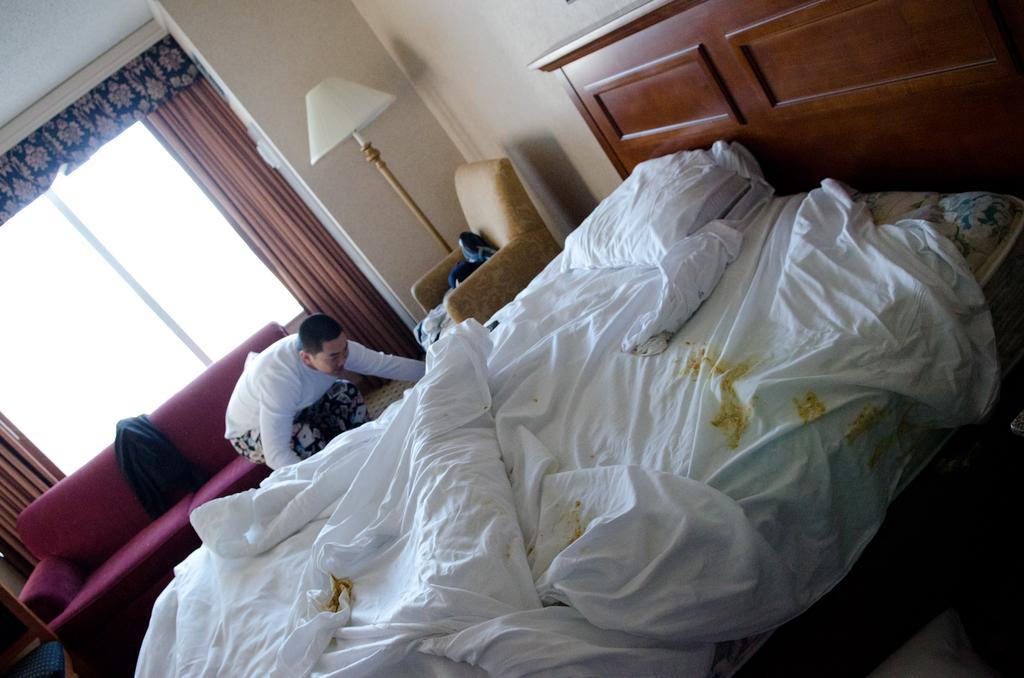Can you describe this image briefly? In this image I can see inside view of the room, in the room I can see a bed , on the bed I can see bed sheet and pillow , beside the bed there is a person , sofa set and couch, lamp and window, curtain , the wall visible. 